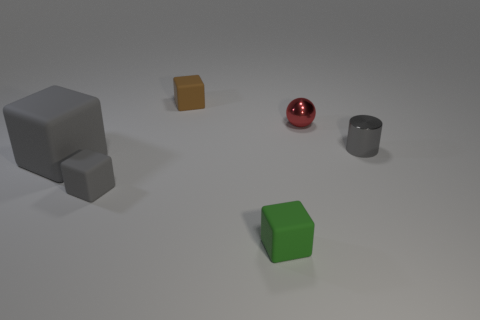Subtract all small cubes. How many cubes are left? 1 Subtract all gray blocks. How many blocks are left? 2 Subtract 2 cubes. How many cubes are left? 2 Add 1 large gray shiny blocks. How many objects exist? 7 Subtract 0 purple cylinders. How many objects are left? 6 Subtract all blocks. How many objects are left? 2 Subtract all red cylinders. Subtract all green blocks. How many cylinders are left? 1 Subtract all yellow balls. How many brown cylinders are left? 0 Subtract all green blocks. Subtract all brown cubes. How many objects are left? 4 Add 3 brown matte cubes. How many brown matte cubes are left? 4 